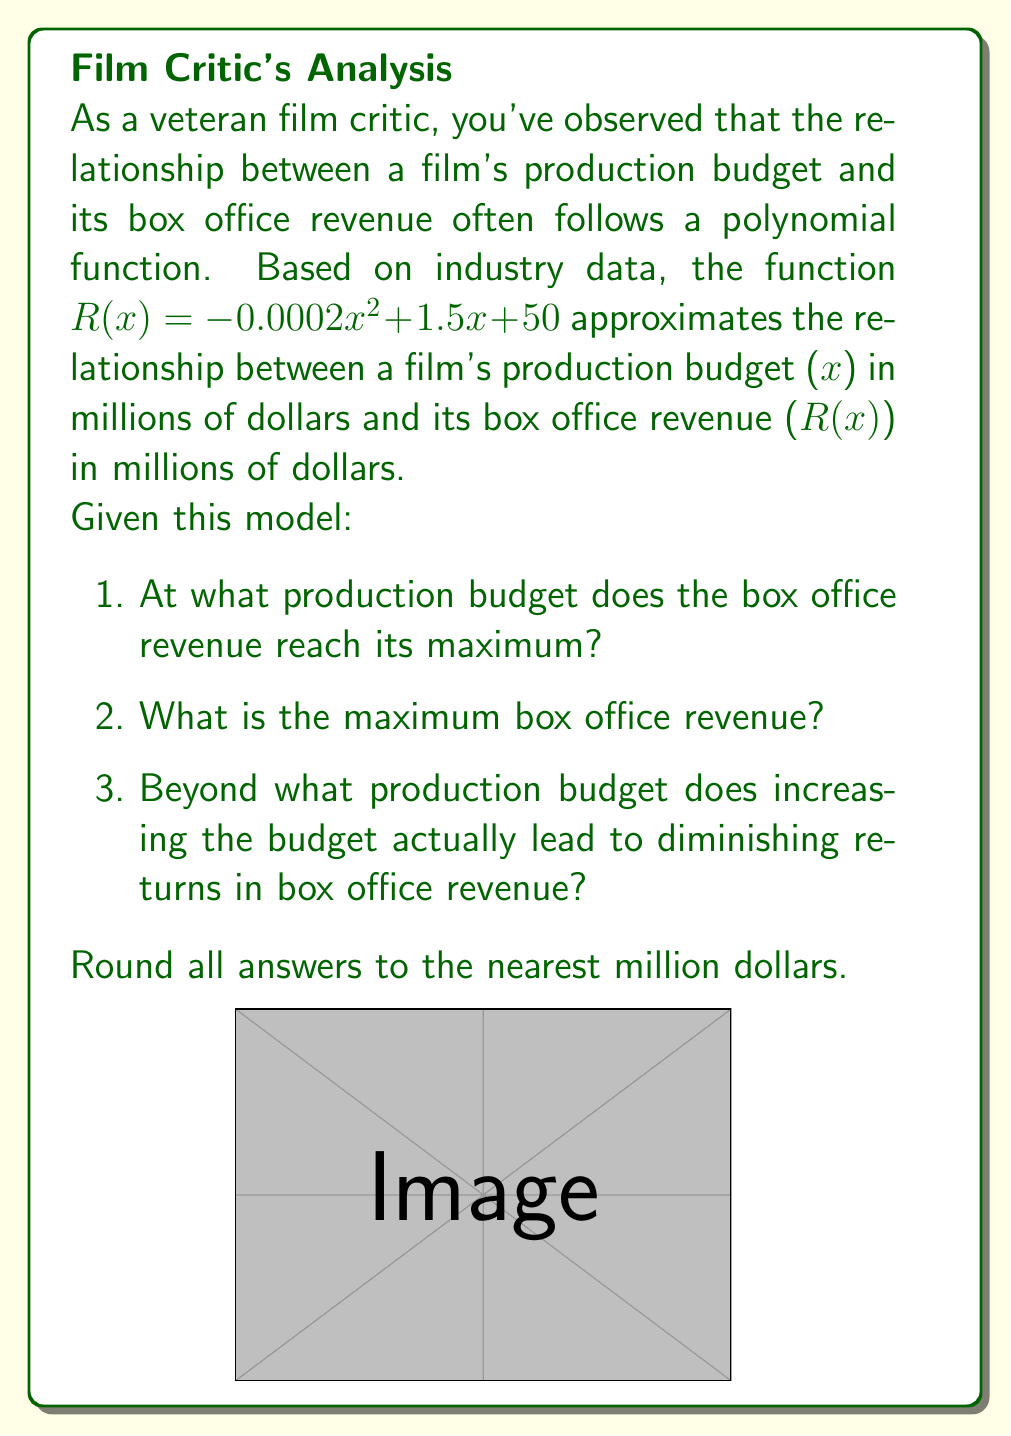Give your solution to this math problem. Let's approach this step-by-step:

1) To find the production budget that maximizes revenue, we need to find the vertex of the parabola. For a quadratic function in the form $f(x) = ax^2 + bx + c$, the x-coordinate of the vertex is given by $x = -\frac{b}{2a}$.

   In our case, $a = -0.0002$, $b = 1.5$, and $c = 50$.

   $x = -\frac{1.5}{2(-0.0002)} = \frac{1.5}{0.0004} = 3750$

2) To find the maximum revenue, we substitute this x-value back into our original function:

   $R(3750) = -0.0002(3750)^2 + 1.5(3750) + 50$
            $= -0.0002(14,062,500) + 5625 + 50$
            $= -2812.5 + 5625 + 50$
            $= 2862.5$

3) The point where increasing the budget leads to diminishing returns is the same as the maximum point we found in step 1, which is $3750$ million dollars.

Rounding to the nearest million:
1) Maximum revenue occurs at a budget of $3750$ million dollars
2) Maximum revenue is $2863$ million dollars
3) Diminishing returns begin after $3750$ million dollars
Answer: 1) $3750 million, 2) $2863 million, 3) $3750 million 